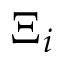<formula> <loc_0><loc_0><loc_500><loc_500>\Xi _ { i }</formula> 